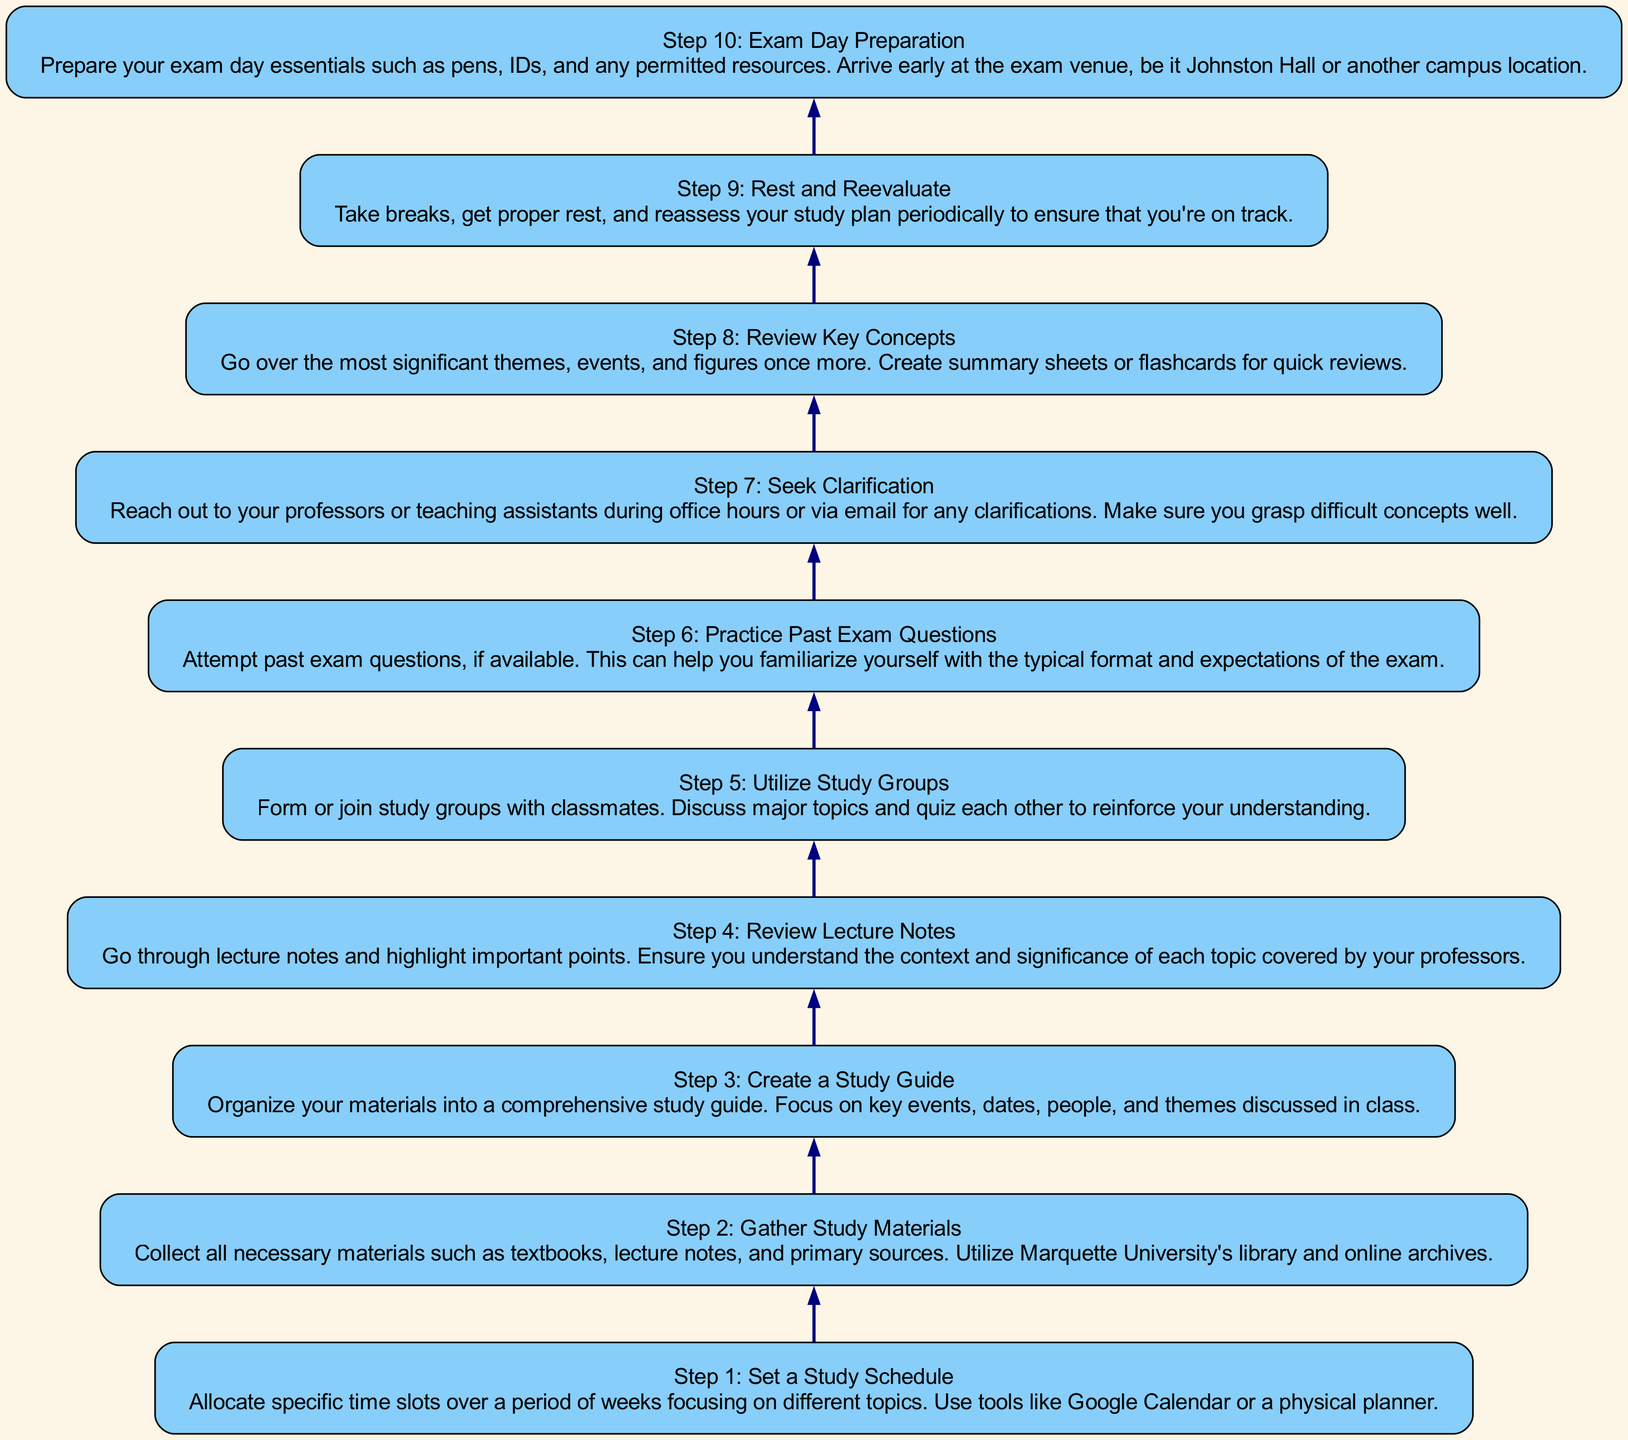What is the first step in preparing for a history exam? The first step listed in the diagram is "Step 1: Set a Study Schedule". This can be found at the bottom of the flow chart as the starting point.
Answer: Step 1: Set a Study Schedule How many steps are there in the diagram? Counting the number of nodes in the diagram, we find there are a total of ten steps listed from Step 1 to Step 10, indicating the complete process for exam preparation.
Answer: 10 What does Step 4 involve? In Step 4, titled "Review Lecture Notes", the description indicates going through lecture notes and highlighting important points while understanding their context and significance.
Answer: Review Lecture Notes Which step follows "Utilize Study Groups"? In the flow chart, "Utilize Study Groups" is Step 5, and it is followed by "Practice Past Exam Questions", which is Step 6. This relationship is indicated by the directed edge connecting these two steps in the diagram.
Answer: Practice Past Exam Questions What is the purpose of Step 7? Step 7 is titled "Seek Clarification", and its purpose is to encourage students to reach out to their professors or teaching assistants for any clarifications needed on difficult concepts. This detail is part of the instruction flow.
Answer: Seek Clarification Which step emphasizes the importance of taking breaks? The step that emphasizes breaks is Step 9, "Rest and Reevaluate". This step suggests taking breaks, getting proper rest, and reassessing the study plan periodically to stay on track.
Answer: Rest and Reevaluate What is the last step in the process? The last step in the diagram is "Step 10: Exam Day Preparation". As illustrated, it detail preparation for the exam day essentials before the actual exam.
Answer: Step 10: Exam Day Preparation How do the first three steps connect? The flow from the first three steps operates sequentially: Step 1 involves setting a schedule, Step 2 requires gathering materials, and Step 3 involves creating a study guide. Each step builds on the completion of the previous one, leading to efficient study preparation.
Answer: They connect sequentially What might be included in the study guide mentioned in Step 3? The study guide, as described in Step 3, should include key events, dates, people, and themes that were discussed in lecture as part of the comprehensive study materials.
Answer: Key events, dates, people, and themes Which step suggests using resources from the library? Step 2, "Gather Study Materials", specifically mentions utilizing Marquette University's library and online archives to collect necessary study materials, indicating resources available for students.
Answer: Gather Study Materials 